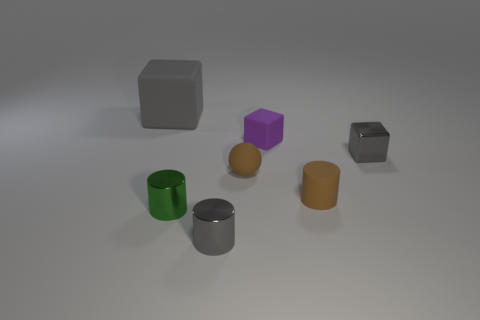Subtract all gray metallic cylinders. How many cylinders are left? 2 Subtract all gray blocks. How many blocks are left? 1 Add 1 small gray metallic cylinders. How many objects exist? 8 Subtract 1 spheres. How many spheres are left? 0 Subtract all brown balls. How many gray cubes are left? 2 Subtract all spheres. How many objects are left? 6 Subtract all brown blocks. Subtract all cyan spheres. How many blocks are left? 3 Subtract all brown matte blocks. Subtract all brown cylinders. How many objects are left? 6 Add 1 tiny green metallic objects. How many tiny green metallic objects are left? 2 Add 1 large things. How many large things exist? 2 